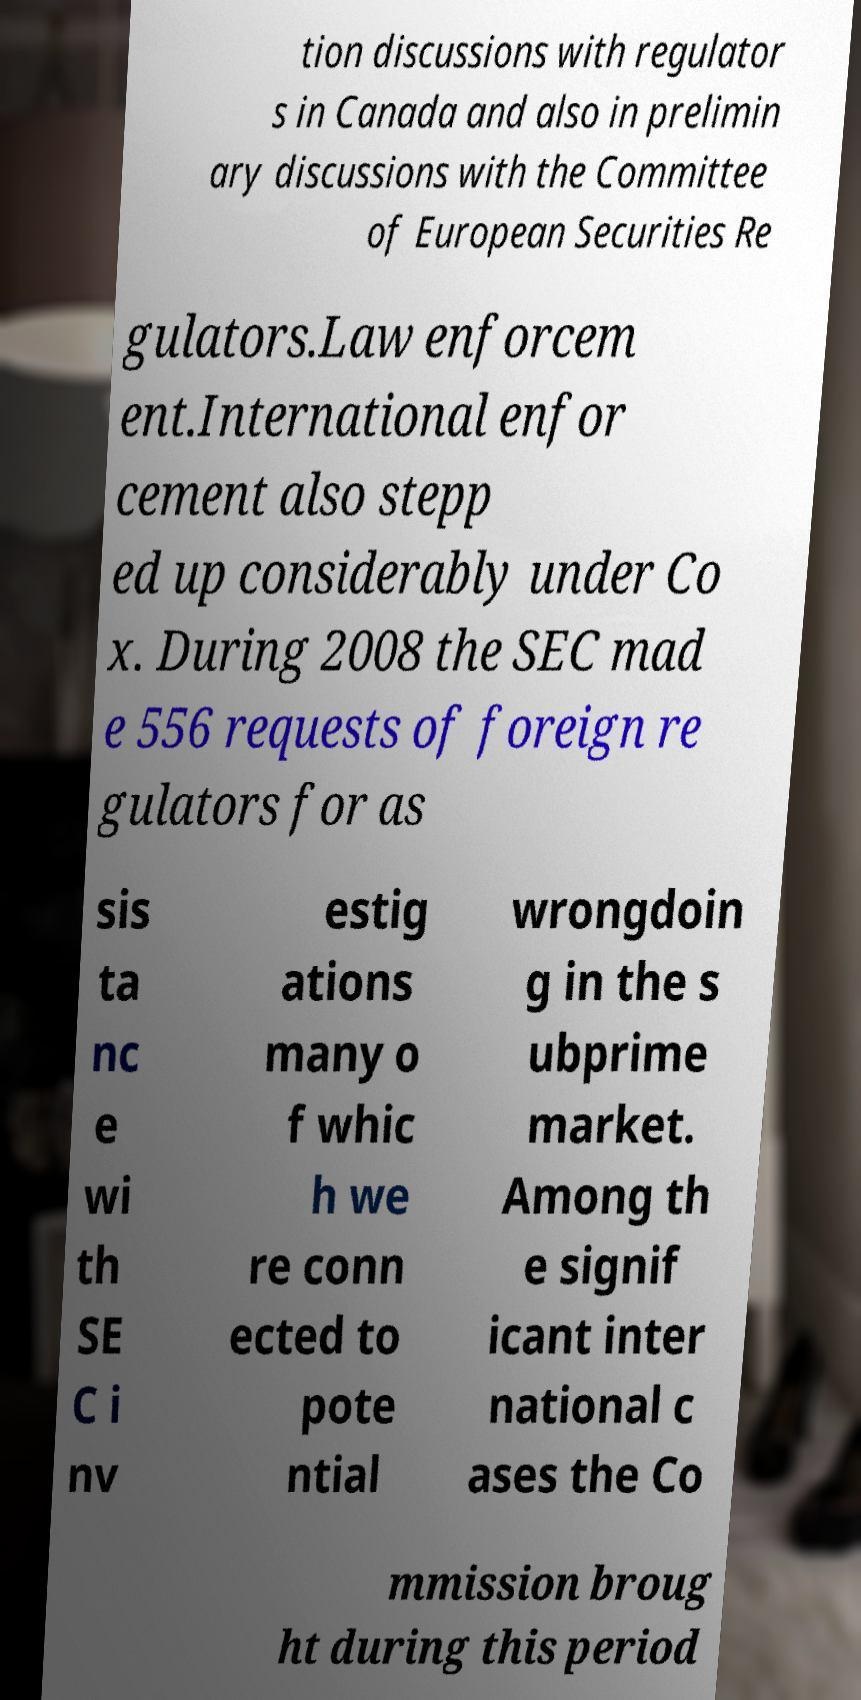Please read and relay the text visible in this image. What does it say? tion discussions with regulator s in Canada and also in prelimin ary discussions with the Committee of European Securities Re gulators.Law enforcem ent.International enfor cement also stepp ed up considerably under Co x. During 2008 the SEC mad e 556 requests of foreign re gulators for as sis ta nc e wi th SE C i nv estig ations many o f whic h we re conn ected to pote ntial wrongdoin g in the s ubprime market. Among th e signif icant inter national c ases the Co mmission broug ht during this period 